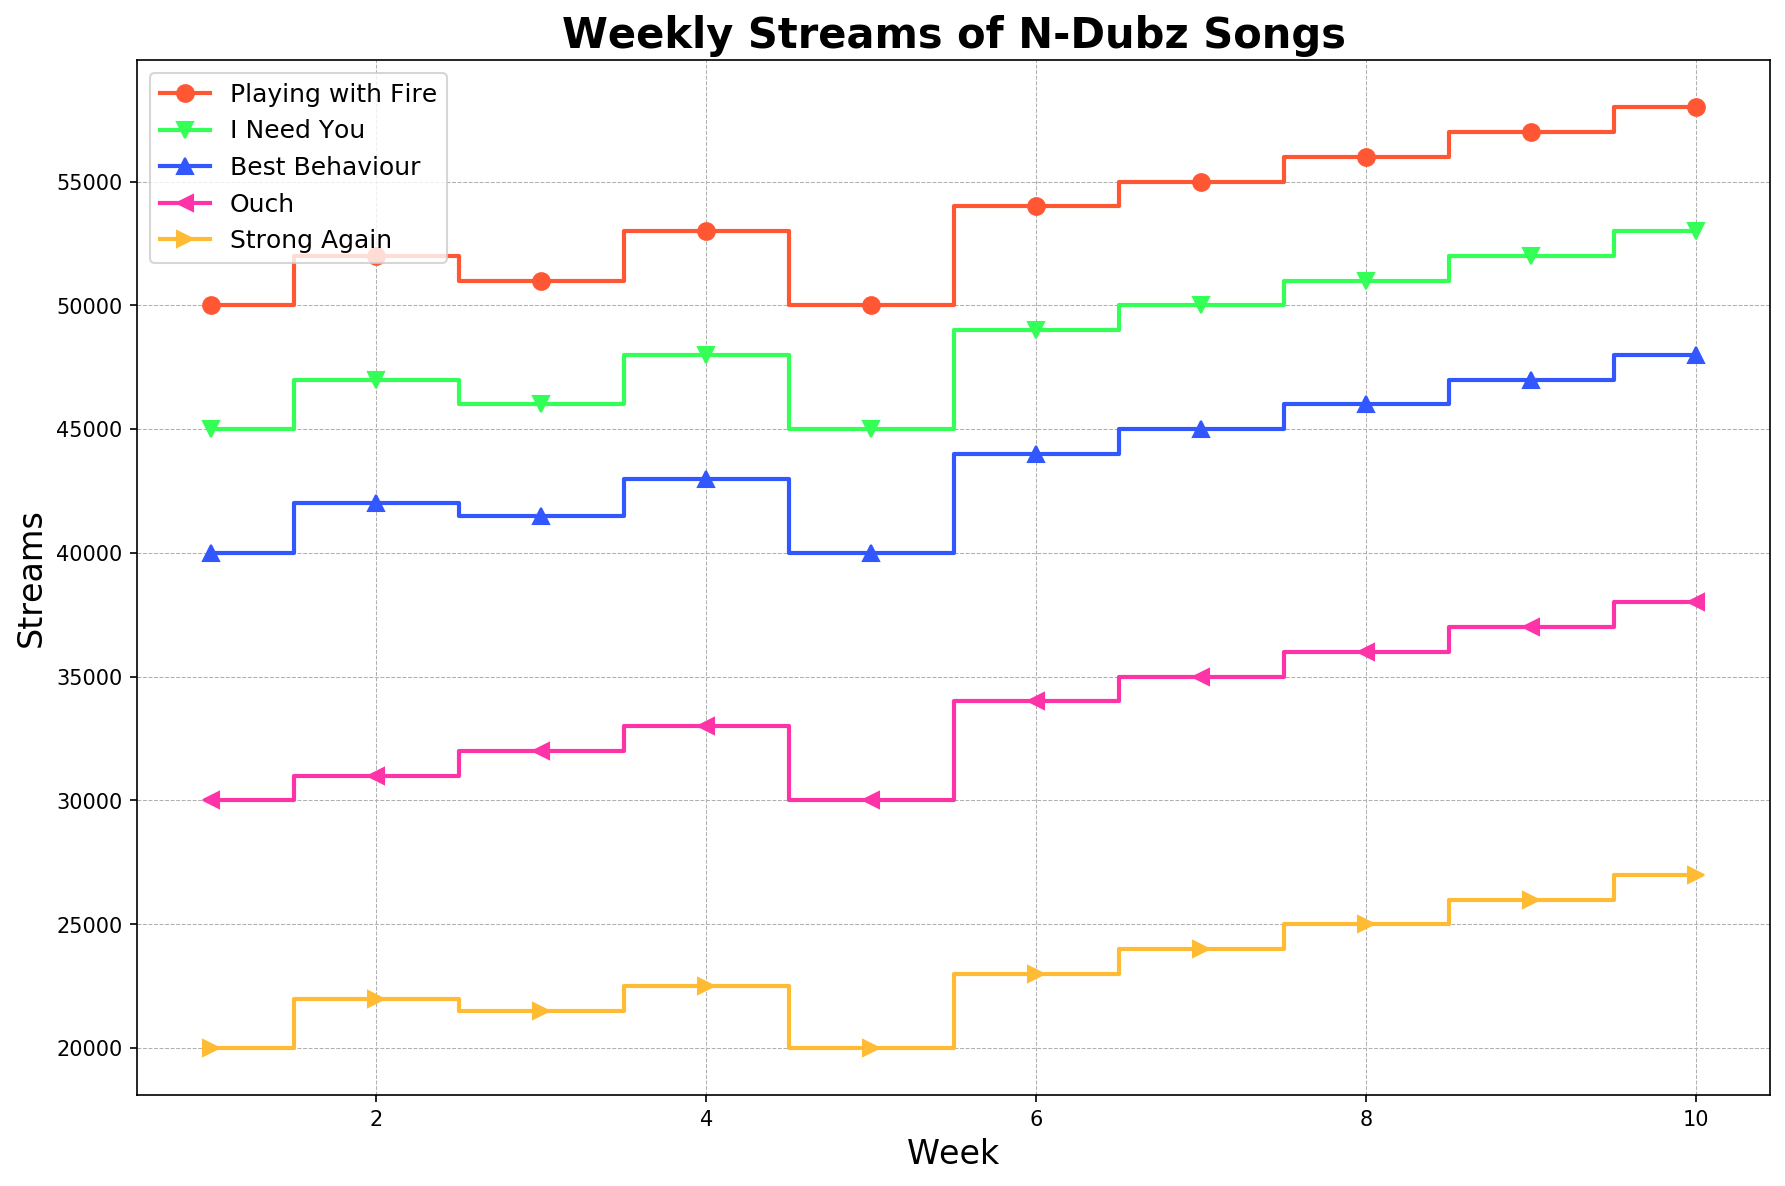What's the trend of weekly streams for “Playing with Fire”? From week 1 to week 10, the number of streams for "Playing with Fire" consistently increases. Starting at 50,000 in week 1, it gradually rises, reaching 58,000 in week 10. The plot shows a steady upward trend for this song.
Answer: Increasing Which song has the most dramatic increase in weekly streams from week 1 to week 10? By looking at the height increments between week 1 and week 10 across all songs, "Playing with Fire" emerges as having the largest increase: starting at 50,000 and ending at 58,000, the song shows an increase of 8,000 streams.
Answer: Playing with Fire Comparing the streams in week 5, which song has the least number of streams? By comparing the height of the stairs plots at week 5, "Strong Again" has the shortest bar, indicating it has the fewest streams among the songs, with a count of 20,000.
Answer: Strong Again What is the average number of weekly streams for "I Need You" over 10 weeks? The weekly streams for "I Need You" are: 45000, 47000, 46000, 48000, 45000, 49000, 50000, 51000, 52000, 53000. Summing these, we get 476000. Dividing by 10 weeks gives an average of 476000/10 = 47600.
Answer: 47,600 Between weeks 4 and 6, which song shows the biggest percentage increase in streams? For each song, calculate the percentage increase: "Playing with Fire" (54000 - 53000) / 53000 = 1.89%, "I Need You" (49000 - 48000) / 48000 = 2.08%, "Best Behaviour" (44000 - 43000) / 43000 = 2.33%, "Ouch" (34000 - 33000) / 33000 = 3.03%, "Strong Again" (23000 - 22500) / 22500 = 2.22%. "Ouch" shows the biggest percentage increase.
Answer: Ouch Which song experiences the least variation in weekly streams? By visually inspecting the plot, "Best Behaviour" and "Strong Again" show less vertical spacing between weeks compared to other songs. Calculating the differences: "Best Behaviour" from 40000 to 48000 (change of 8000), "Strong Again" from 20000 to 27000 (change of 7000). "Strong Again" has the least variation.
Answer: Strong Again In which week do all songs show the highest number of streams collectively? Sum the streams for all songs each week and compare: Week 10 for instance is "58000 + 53000 + 48000 + 38000 + 27000 = 224000". Checking other weeks shows no other week exceeds this total.
Answer: Week 10 